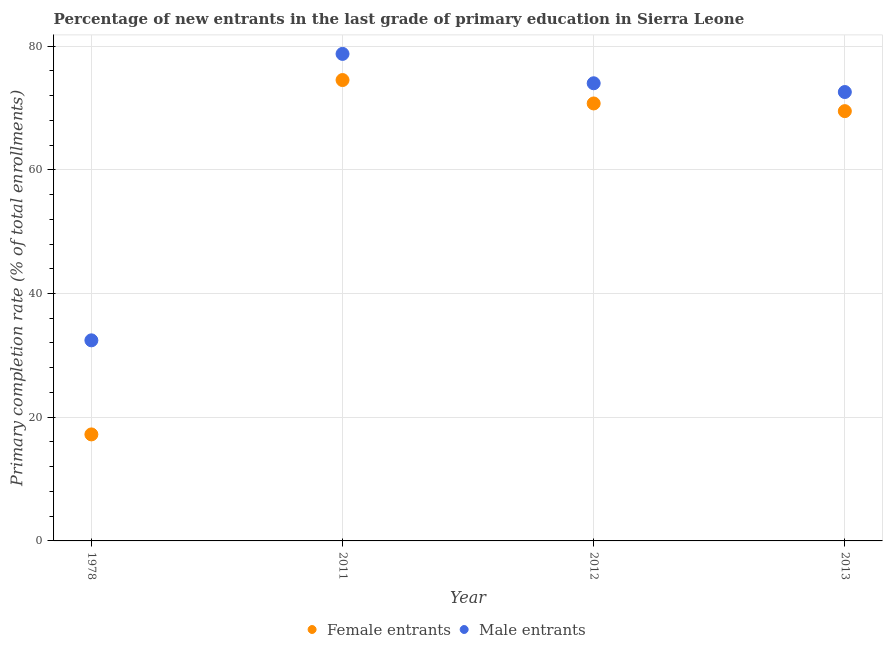What is the primary completion rate of female entrants in 2013?
Ensure brevity in your answer.  69.49. Across all years, what is the maximum primary completion rate of male entrants?
Make the answer very short. 78.74. Across all years, what is the minimum primary completion rate of female entrants?
Offer a very short reply. 17.22. In which year was the primary completion rate of male entrants minimum?
Keep it short and to the point. 1978. What is the total primary completion rate of female entrants in the graph?
Ensure brevity in your answer.  231.94. What is the difference between the primary completion rate of female entrants in 2011 and that in 2012?
Your answer should be compact. 3.79. What is the difference between the primary completion rate of male entrants in 1978 and the primary completion rate of female entrants in 2013?
Provide a succinct answer. -37.06. What is the average primary completion rate of female entrants per year?
Offer a very short reply. 57.99. In the year 1978, what is the difference between the primary completion rate of male entrants and primary completion rate of female entrants?
Provide a short and direct response. 15.21. What is the ratio of the primary completion rate of female entrants in 1978 to that in 2011?
Your response must be concise. 0.23. Is the difference between the primary completion rate of female entrants in 2011 and 2013 greater than the difference between the primary completion rate of male entrants in 2011 and 2013?
Offer a very short reply. No. What is the difference between the highest and the second highest primary completion rate of male entrants?
Offer a terse response. 4.75. What is the difference between the highest and the lowest primary completion rate of female entrants?
Make the answer very short. 57.29. In how many years, is the primary completion rate of male entrants greater than the average primary completion rate of male entrants taken over all years?
Ensure brevity in your answer.  3. Is the primary completion rate of female entrants strictly less than the primary completion rate of male entrants over the years?
Your answer should be very brief. Yes. What is the difference between two consecutive major ticks on the Y-axis?
Your answer should be compact. 20. Are the values on the major ticks of Y-axis written in scientific E-notation?
Your response must be concise. No. Does the graph contain grids?
Ensure brevity in your answer.  Yes. Where does the legend appear in the graph?
Offer a terse response. Bottom center. What is the title of the graph?
Ensure brevity in your answer.  Percentage of new entrants in the last grade of primary education in Sierra Leone. Does "Primary education" appear as one of the legend labels in the graph?
Ensure brevity in your answer.  No. What is the label or title of the X-axis?
Make the answer very short. Year. What is the label or title of the Y-axis?
Your answer should be compact. Primary completion rate (% of total enrollments). What is the Primary completion rate (% of total enrollments) of Female entrants in 1978?
Make the answer very short. 17.22. What is the Primary completion rate (% of total enrollments) of Male entrants in 1978?
Your response must be concise. 32.43. What is the Primary completion rate (% of total enrollments) of Female entrants in 2011?
Offer a terse response. 74.51. What is the Primary completion rate (% of total enrollments) in Male entrants in 2011?
Ensure brevity in your answer.  78.74. What is the Primary completion rate (% of total enrollments) of Female entrants in 2012?
Keep it short and to the point. 70.73. What is the Primary completion rate (% of total enrollments) in Male entrants in 2012?
Offer a terse response. 73.99. What is the Primary completion rate (% of total enrollments) in Female entrants in 2013?
Your response must be concise. 69.49. What is the Primary completion rate (% of total enrollments) in Male entrants in 2013?
Offer a very short reply. 72.57. Across all years, what is the maximum Primary completion rate (% of total enrollments) in Female entrants?
Provide a succinct answer. 74.51. Across all years, what is the maximum Primary completion rate (% of total enrollments) of Male entrants?
Keep it short and to the point. 78.74. Across all years, what is the minimum Primary completion rate (% of total enrollments) of Female entrants?
Your answer should be very brief. 17.22. Across all years, what is the minimum Primary completion rate (% of total enrollments) of Male entrants?
Your response must be concise. 32.43. What is the total Primary completion rate (% of total enrollments) in Female entrants in the graph?
Ensure brevity in your answer.  231.94. What is the total Primary completion rate (% of total enrollments) in Male entrants in the graph?
Your answer should be very brief. 257.73. What is the difference between the Primary completion rate (% of total enrollments) in Female entrants in 1978 and that in 2011?
Provide a succinct answer. -57.29. What is the difference between the Primary completion rate (% of total enrollments) of Male entrants in 1978 and that in 2011?
Give a very brief answer. -46.31. What is the difference between the Primary completion rate (% of total enrollments) of Female entrants in 1978 and that in 2012?
Keep it short and to the point. -53.51. What is the difference between the Primary completion rate (% of total enrollments) in Male entrants in 1978 and that in 2012?
Make the answer very short. -41.56. What is the difference between the Primary completion rate (% of total enrollments) in Female entrants in 1978 and that in 2013?
Provide a succinct answer. -52.27. What is the difference between the Primary completion rate (% of total enrollments) of Male entrants in 1978 and that in 2013?
Provide a short and direct response. -40.14. What is the difference between the Primary completion rate (% of total enrollments) in Female entrants in 2011 and that in 2012?
Your answer should be very brief. 3.79. What is the difference between the Primary completion rate (% of total enrollments) of Male entrants in 2011 and that in 2012?
Offer a very short reply. 4.75. What is the difference between the Primary completion rate (% of total enrollments) of Female entrants in 2011 and that in 2013?
Ensure brevity in your answer.  5.03. What is the difference between the Primary completion rate (% of total enrollments) of Male entrants in 2011 and that in 2013?
Give a very brief answer. 6.16. What is the difference between the Primary completion rate (% of total enrollments) in Female entrants in 2012 and that in 2013?
Provide a short and direct response. 1.24. What is the difference between the Primary completion rate (% of total enrollments) of Male entrants in 2012 and that in 2013?
Provide a succinct answer. 1.42. What is the difference between the Primary completion rate (% of total enrollments) in Female entrants in 1978 and the Primary completion rate (% of total enrollments) in Male entrants in 2011?
Offer a very short reply. -61.52. What is the difference between the Primary completion rate (% of total enrollments) of Female entrants in 1978 and the Primary completion rate (% of total enrollments) of Male entrants in 2012?
Give a very brief answer. -56.77. What is the difference between the Primary completion rate (% of total enrollments) of Female entrants in 1978 and the Primary completion rate (% of total enrollments) of Male entrants in 2013?
Give a very brief answer. -55.35. What is the difference between the Primary completion rate (% of total enrollments) of Female entrants in 2011 and the Primary completion rate (% of total enrollments) of Male entrants in 2012?
Your answer should be compact. 0.52. What is the difference between the Primary completion rate (% of total enrollments) in Female entrants in 2011 and the Primary completion rate (% of total enrollments) in Male entrants in 2013?
Give a very brief answer. 1.94. What is the difference between the Primary completion rate (% of total enrollments) of Female entrants in 2012 and the Primary completion rate (% of total enrollments) of Male entrants in 2013?
Keep it short and to the point. -1.85. What is the average Primary completion rate (% of total enrollments) of Female entrants per year?
Offer a very short reply. 57.99. What is the average Primary completion rate (% of total enrollments) of Male entrants per year?
Your response must be concise. 64.43. In the year 1978, what is the difference between the Primary completion rate (% of total enrollments) in Female entrants and Primary completion rate (% of total enrollments) in Male entrants?
Offer a very short reply. -15.21. In the year 2011, what is the difference between the Primary completion rate (% of total enrollments) in Female entrants and Primary completion rate (% of total enrollments) in Male entrants?
Provide a succinct answer. -4.23. In the year 2012, what is the difference between the Primary completion rate (% of total enrollments) in Female entrants and Primary completion rate (% of total enrollments) in Male entrants?
Offer a terse response. -3.26. In the year 2013, what is the difference between the Primary completion rate (% of total enrollments) of Female entrants and Primary completion rate (% of total enrollments) of Male entrants?
Provide a short and direct response. -3.09. What is the ratio of the Primary completion rate (% of total enrollments) in Female entrants in 1978 to that in 2011?
Ensure brevity in your answer.  0.23. What is the ratio of the Primary completion rate (% of total enrollments) in Male entrants in 1978 to that in 2011?
Your response must be concise. 0.41. What is the ratio of the Primary completion rate (% of total enrollments) in Female entrants in 1978 to that in 2012?
Your answer should be very brief. 0.24. What is the ratio of the Primary completion rate (% of total enrollments) of Male entrants in 1978 to that in 2012?
Keep it short and to the point. 0.44. What is the ratio of the Primary completion rate (% of total enrollments) of Female entrants in 1978 to that in 2013?
Your answer should be compact. 0.25. What is the ratio of the Primary completion rate (% of total enrollments) in Male entrants in 1978 to that in 2013?
Provide a short and direct response. 0.45. What is the ratio of the Primary completion rate (% of total enrollments) in Female entrants in 2011 to that in 2012?
Make the answer very short. 1.05. What is the ratio of the Primary completion rate (% of total enrollments) of Male entrants in 2011 to that in 2012?
Your response must be concise. 1.06. What is the ratio of the Primary completion rate (% of total enrollments) in Female entrants in 2011 to that in 2013?
Your response must be concise. 1.07. What is the ratio of the Primary completion rate (% of total enrollments) of Male entrants in 2011 to that in 2013?
Offer a terse response. 1.08. What is the ratio of the Primary completion rate (% of total enrollments) in Female entrants in 2012 to that in 2013?
Your answer should be very brief. 1.02. What is the ratio of the Primary completion rate (% of total enrollments) in Male entrants in 2012 to that in 2013?
Keep it short and to the point. 1.02. What is the difference between the highest and the second highest Primary completion rate (% of total enrollments) of Female entrants?
Provide a succinct answer. 3.79. What is the difference between the highest and the second highest Primary completion rate (% of total enrollments) of Male entrants?
Your response must be concise. 4.75. What is the difference between the highest and the lowest Primary completion rate (% of total enrollments) of Female entrants?
Keep it short and to the point. 57.29. What is the difference between the highest and the lowest Primary completion rate (% of total enrollments) of Male entrants?
Keep it short and to the point. 46.31. 